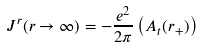Convert formula to latex. <formula><loc_0><loc_0><loc_500><loc_500>J ^ { r } ( r \rightarrow \infty ) = - \frac { e ^ { 2 } } { 2 \pi } \left ( A _ { t } ( r _ { + } ) \right )</formula> 